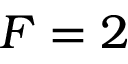Convert formula to latex. <formula><loc_0><loc_0><loc_500><loc_500>F = 2</formula> 